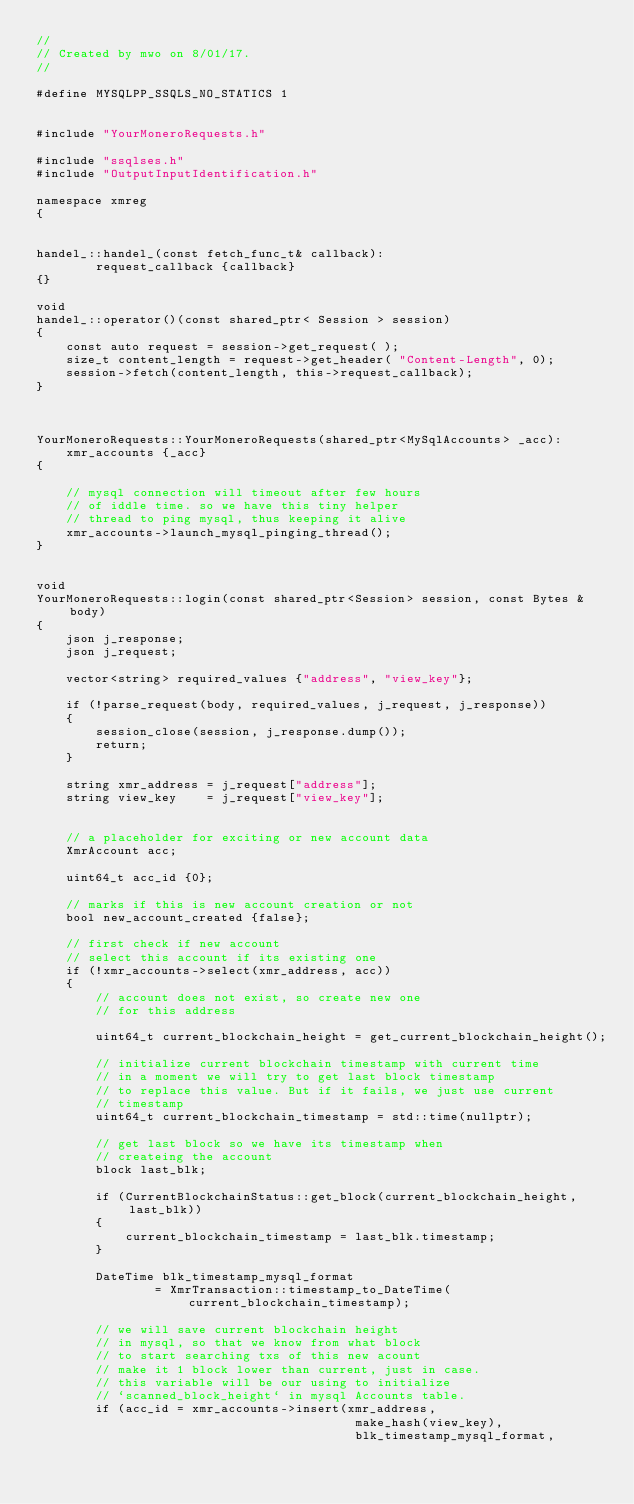<code> <loc_0><loc_0><loc_500><loc_500><_C++_>//
// Created by mwo on 8/01/17.
//

#define MYSQLPP_SSQLS_NO_STATICS 1


#include "YourMoneroRequests.h"

#include "ssqlses.h"
#include "OutputInputIdentification.h"

namespace xmreg
{


handel_::handel_(const fetch_func_t& callback):
        request_callback {callback}
{}

void
handel_::operator()(const shared_ptr< Session > session)
{
    const auto request = session->get_request( );
    size_t content_length = request->get_header( "Content-Length", 0);
    session->fetch(content_length, this->request_callback);
}



YourMoneroRequests::YourMoneroRequests(shared_ptr<MySqlAccounts> _acc):
    xmr_accounts {_acc}
{

    // mysql connection will timeout after few hours
    // of iddle time. so we have this tiny helper
    // thread to ping mysql, thus keeping it alive
    xmr_accounts->launch_mysql_pinging_thread();
}


void
YourMoneroRequests::login(const shared_ptr<Session> session, const Bytes & body)
{
    json j_response;
    json j_request;

    vector<string> required_values {"address", "view_key"};

    if (!parse_request(body, required_values, j_request, j_response))
    {
        session_close(session, j_response.dump());
        return;
    }

    string xmr_address = j_request["address"];
    string view_key    = j_request["view_key"];


    // a placeholder for exciting or new account data
    XmrAccount acc;

    uint64_t acc_id {0};

    // marks if this is new account creation or not
    bool new_account_created {false};

    // first check if new account
    // select this account if its existing one
    if (!xmr_accounts->select(xmr_address, acc))
    {
        // account does not exist, so create new one
        // for this address

        uint64_t current_blockchain_height = get_current_blockchain_height();

        // initialize current blockchain timestamp with current time
        // in a moment we will try to get last block timestamp
        // to replace this value. But if it fails, we just use current
        // timestamp
        uint64_t current_blockchain_timestamp = std::time(nullptr);

        // get last block so we have its timestamp when
        // createing the account
        block last_blk;

        if (CurrentBlockchainStatus::get_block(current_blockchain_height, last_blk))
        {
            current_blockchain_timestamp = last_blk.timestamp;
        }

        DateTime blk_timestamp_mysql_format
                = XmrTransaction::timestamp_to_DateTime(current_blockchain_timestamp);

        // we will save current blockchain height
        // in mysql, so that we know from what block
        // to start searching txs of this new acount
        // make it 1 block lower than current, just in case.
        // this variable will be our using to initialize
        // `scanned_block_height` in mysql Accounts table.
        if (acc_id = xmr_accounts->insert(xmr_address,
                                           make_hash(view_key),
                                           blk_timestamp_mysql_format,</code> 